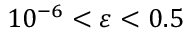<formula> <loc_0><loc_0><loc_500><loc_500>1 0 ^ { - 6 } < \varepsilon < 0 . 5</formula> 